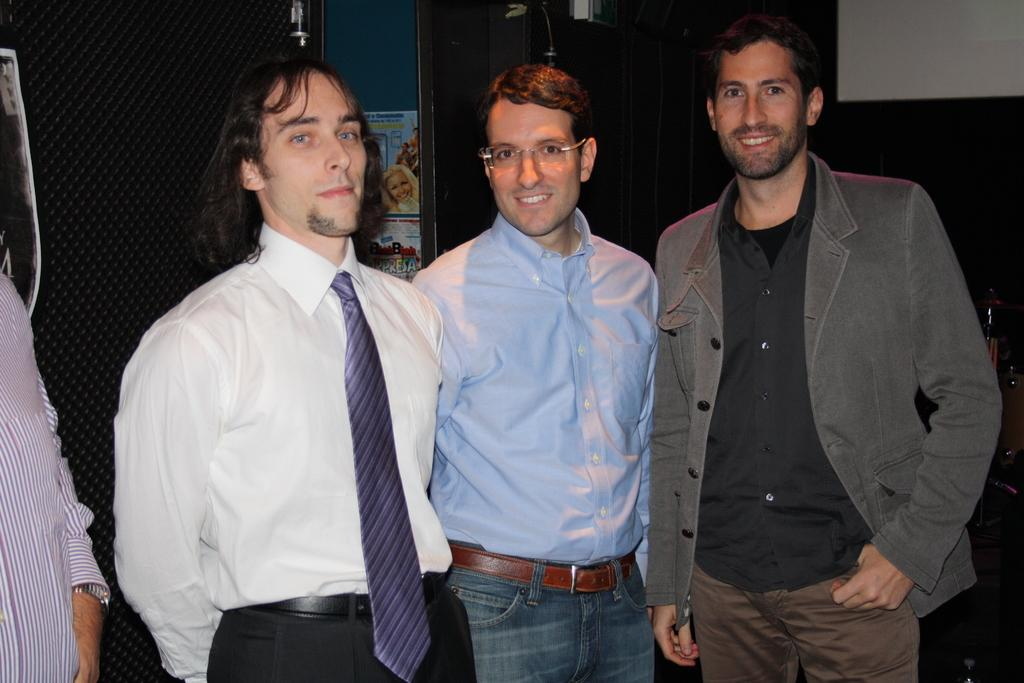What can be seen in the center of the image? There are three men with smiley faces in the center of the image. Who is on the left side of the image? There is a person on the left side of the image. What can be found in the background of the image? There are objects, a calendar, a poster, and a wall in the background of the image. What type of property is the rabbit standing on in the image? There is no rabbit present in the image, so it is not possible to determine what type of property it might be standing on. What is the weight of the objects on the scale in the image? There is no scale present in the image, so it is not possible to determine the weight of any objects. 